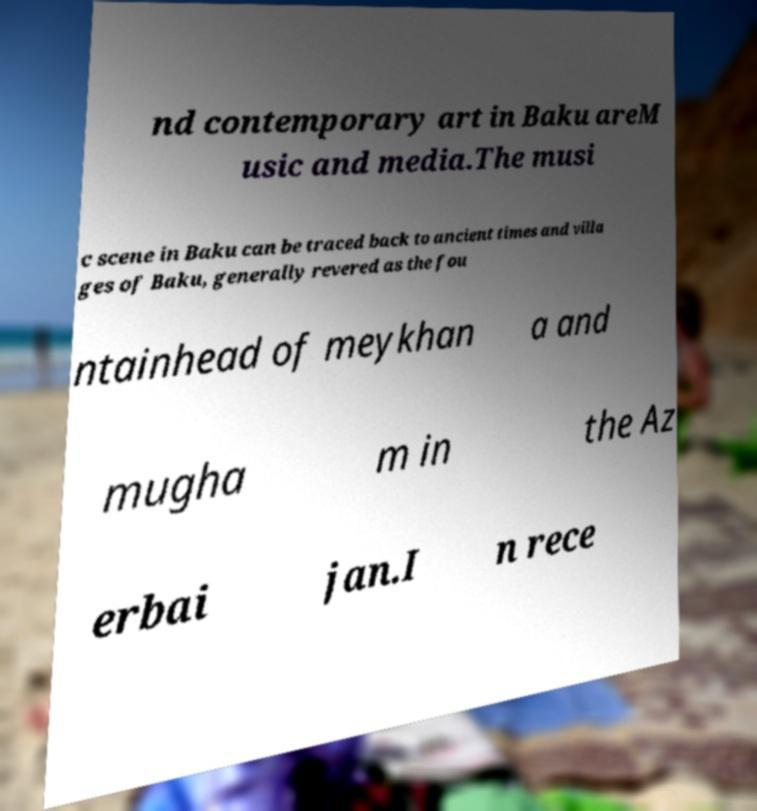Could you extract and type out the text from this image? nd contemporary art in Baku areM usic and media.The musi c scene in Baku can be traced back to ancient times and villa ges of Baku, generally revered as the fou ntainhead of meykhan a and mugha m in the Az erbai jan.I n rece 